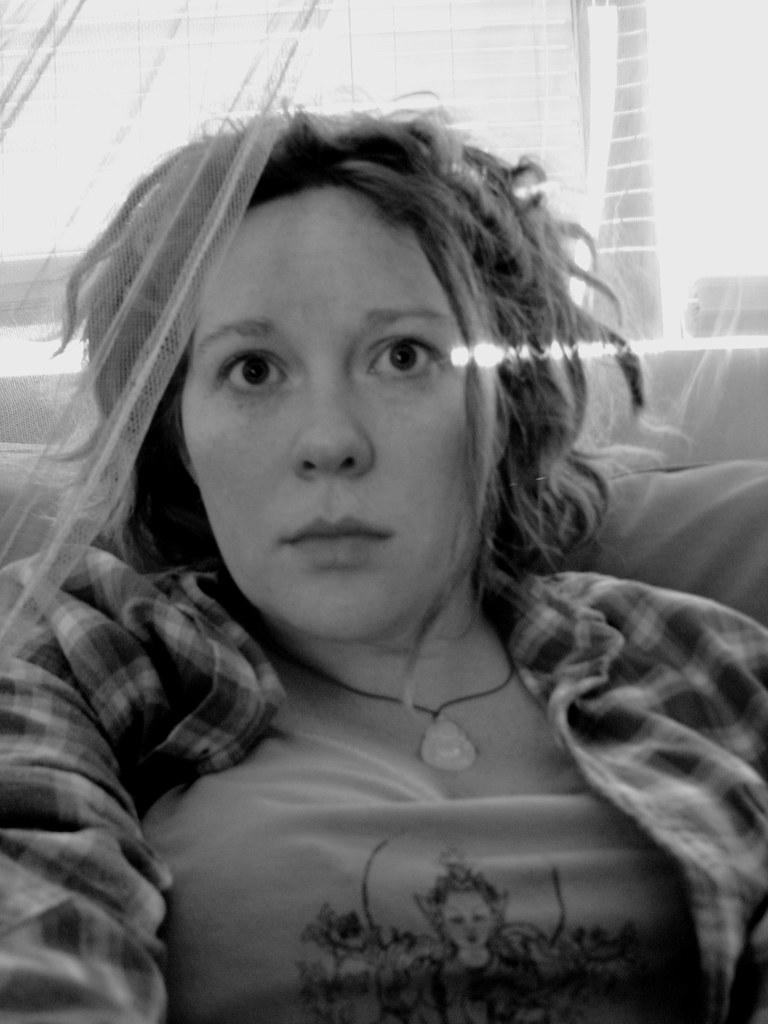What can be seen in the image? There is a person in the image. What is the person wearing? The person is wearing a check-shirt and a t-shirt. What is visible in the background of the image? There is a window blind and a curtain in the background of the image. What is the color scheme of the image? The image is black and white. What time of day is the person's aunt arriving in the image? There is no mention of an aunt or a specific time of day in the image. The image is black and white, so it is impossible to determine the time of day based on the lighting. 